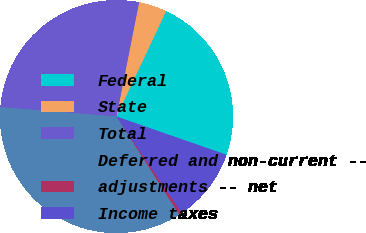Convert chart. <chart><loc_0><loc_0><loc_500><loc_500><pie_chart><fcel>Federal<fcel>State<fcel>Total<fcel>Deferred and non-current --<fcel>adjustments -- net<fcel>Income taxes<nl><fcel>23.33%<fcel>3.89%<fcel>26.82%<fcel>35.36%<fcel>0.39%<fcel>10.22%<nl></chart> 